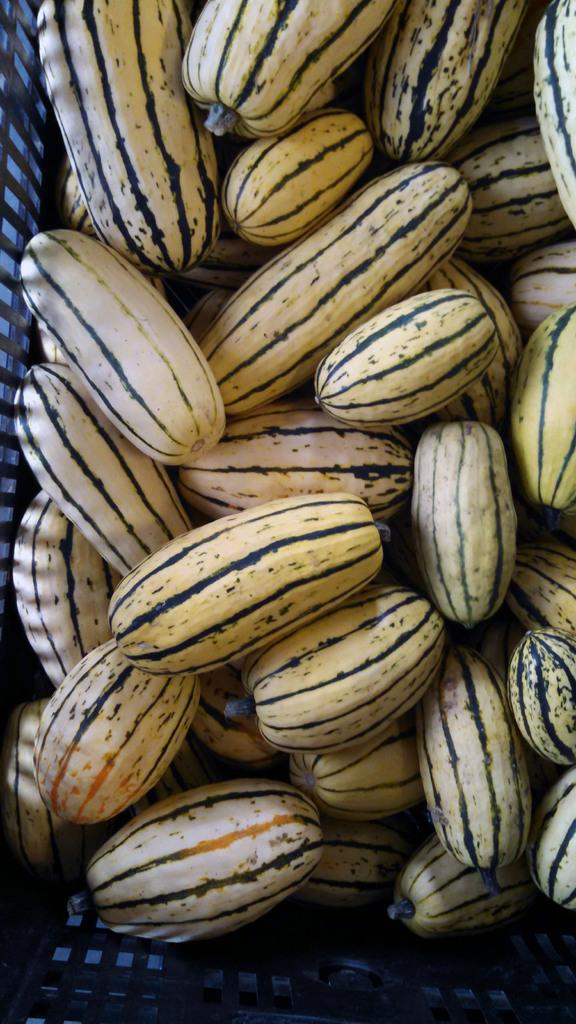What type of food can be seen in the image? There are fruits in the image. What type of horse can be seen whistling in the image? There are no horses or whistling in the image; it features fruits. What type of blade is being used to cut the fruits in the image? There is no blade present in the image; it only shows fruits. 